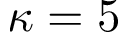<formula> <loc_0><loc_0><loc_500><loc_500>\kappa = 5</formula> 